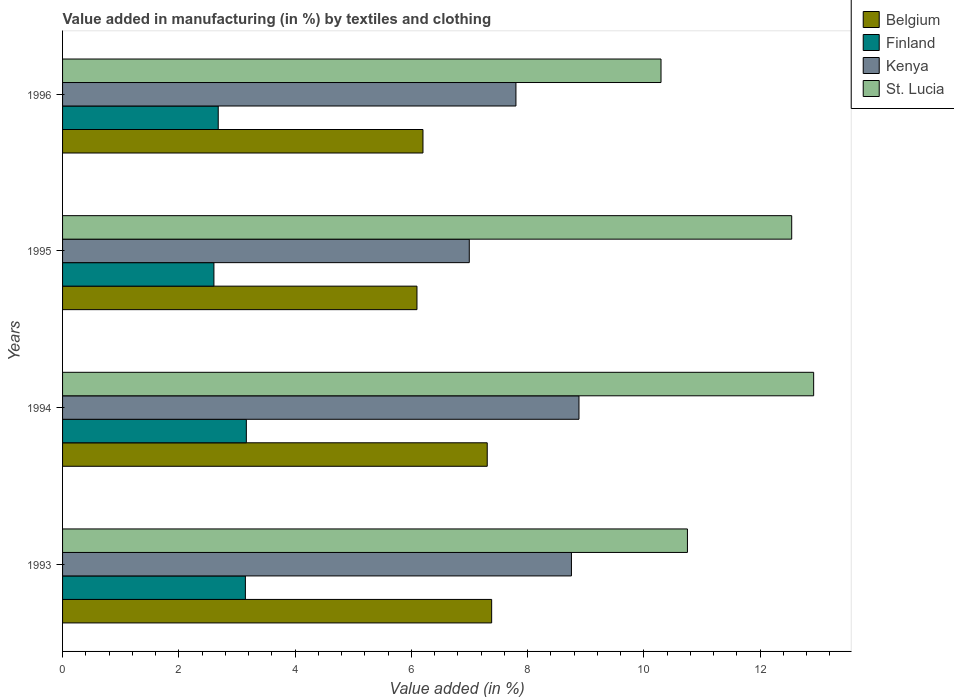Are the number of bars per tick equal to the number of legend labels?
Make the answer very short. Yes. How many bars are there on the 4th tick from the top?
Give a very brief answer. 4. How many bars are there on the 4th tick from the bottom?
Offer a very short reply. 4. What is the label of the 2nd group of bars from the top?
Give a very brief answer. 1995. In how many cases, is the number of bars for a given year not equal to the number of legend labels?
Your response must be concise. 0. What is the percentage of value added in manufacturing by textiles and clothing in St. Lucia in 1993?
Give a very brief answer. 10.75. Across all years, what is the maximum percentage of value added in manufacturing by textiles and clothing in Kenya?
Keep it short and to the point. 8.88. Across all years, what is the minimum percentage of value added in manufacturing by textiles and clothing in St. Lucia?
Provide a succinct answer. 10.29. In which year was the percentage of value added in manufacturing by textiles and clothing in Kenya minimum?
Your response must be concise. 1995. What is the total percentage of value added in manufacturing by textiles and clothing in Finland in the graph?
Keep it short and to the point. 11.59. What is the difference between the percentage of value added in manufacturing by textiles and clothing in Finland in 1994 and that in 1996?
Make the answer very short. 0.48. What is the difference between the percentage of value added in manufacturing by textiles and clothing in Belgium in 1994 and the percentage of value added in manufacturing by textiles and clothing in St. Lucia in 1996?
Make the answer very short. -2.99. What is the average percentage of value added in manufacturing by textiles and clothing in Finland per year?
Provide a succinct answer. 2.9. In the year 1996, what is the difference between the percentage of value added in manufacturing by textiles and clothing in Belgium and percentage of value added in manufacturing by textiles and clothing in Finland?
Keep it short and to the point. 3.52. What is the ratio of the percentage of value added in manufacturing by textiles and clothing in Kenya in 1993 to that in 1995?
Give a very brief answer. 1.25. Is the percentage of value added in manufacturing by textiles and clothing in St. Lucia in 1993 less than that in 1995?
Offer a terse response. Yes. Is the difference between the percentage of value added in manufacturing by textiles and clothing in Belgium in 1994 and 1995 greater than the difference between the percentage of value added in manufacturing by textiles and clothing in Finland in 1994 and 1995?
Offer a very short reply. Yes. What is the difference between the highest and the second highest percentage of value added in manufacturing by textiles and clothing in Kenya?
Offer a terse response. 0.13. What is the difference between the highest and the lowest percentage of value added in manufacturing by textiles and clothing in Belgium?
Offer a very short reply. 1.28. In how many years, is the percentage of value added in manufacturing by textiles and clothing in Finland greater than the average percentage of value added in manufacturing by textiles and clothing in Finland taken over all years?
Give a very brief answer. 2. What does the 4th bar from the bottom in 1995 represents?
Make the answer very short. St. Lucia. How many bars are there?
Provide a succinct answer. 16. What is the difference between two consecutive major ticks on the X-axis?
Keep it short and to the point. 2. Are the values on the major ticks of X-axis written in scientific E-notation?
Make the answer very short. No. Does the graph contain grids?
Your answer should be compact. No. Where does the legend appear in the graph?
Offer a terse response. Top right. How many legend labels are there?
Provide a succinct answer. 4. What is the title of the graph?
Ensure brevity in your answer.  Value added in manufacturing (in %) by textiles and clothing. What is the label or title of the X-axis?
Make the answer very short. Value added (in %). What is the Value added (in %) of Belgium in 1993?
Offer a very short reply. 7.38. What is the Value added (in %) of Finland in 1993?
Your response must be concise. 3.14. What is the Value added (in %) in Kenya in 1993?
Ensure brevity in your answer.  8.75. What is the Value added (in %) in St. Lucia in 1993?
Offer a terse response. 10.75. What is the Value added (in %) in Belgium in 1994?
Your answer should be very brief. 7.3. What is the Value added (in %) of Finland in 1994?
Your response must be concise. 3.16. What is the Value added (in %) in Kenya in 1994?
Your answer should be very brief. 8.88. What is the Value added (in %) in St. Lucia in 1994?
Provide a short and direct response. 12.92. What is the Value added (in %) in Belgium in 1995?
Your answer should be very brief. 6.1. What is the Value added (in %) in Finland in 1995?
Provide a succinct answer. 2.6. What is the Value added (in %) in Kenya in 1995?
Your answer should be compact. 7. What is the Value added (in %) of St. Lucia in 1995?
Your answer should be very brief. 12.54. What is the Value added (in %) of Belgium in 1996?
Your answer should be compact. 6.2. What is the Value added (in %) of Finland in 1996?
Make the answer very short. 2.68. What is the Value added (in %) of Kenya in 1996?
Keep it short and to the point. 7.8. What is the Value added (in %) of St. Lucia in 1996?
Keep it short and to the point. 10.29. Across all years, what is the maximum Value added (in %) in Belgium?
Provide a short and direct response. 7.38. Across all years, what is the maximum Value added (in %) of Finland?
Provide a succinct answer. 3.16. Across all years, what is the maximum Value added (in %) of Kenya?
Your answer should be very brief. 8.88. Across all years, what is the maximum Value added (in %) in St. Lucia?
Provide a succinct answer. 12.92. Across all years, what is the minimum Value added (in %) of Belgium?
Give a very brief answer. 6.1. Across all years, what is the minimum Value added (in %) of Finland?
Provide a succinct answer. 2.6. Across all years, what is the minimum Value added (in %) of Kenya?
Your answer should be very brief. 7. Across all years, what is the minimum Value added (in %) of St. Lucia?
Your answer should be very brief. 10.29. What is the total Value added (in %) in Belgium in the graph?
Give a very brief answer. 26.98. What is the total Value added (in %) in Finland in the graph?
Ensure brevity in your answer.  11.59. What is the total Value added (in %) of Kenya in the graph?
Ensure brevity in your answer.  32.43. What is the total Value added (in %) in St. Lucia in the graph?
Your answer should be compact. 46.51. What is the difference between the Value added (in %) in Belgium in 1993 and that in 1994?
Ensure brevity in your answer.  0.08. What is the difference between the Value added (in %) in Finland in 1993 and that in 1994?
Your response must be concise. -0.02. What is the difference between the Value added (in %) in Kenya in 1993 and that in 1994?
Your response must be concise. -0.13. What is the difference between the Value added (in %) of St. Lucia in 1993 and that in 1994?
Give a very brief answer. -2.17. What is the difference between the Value added (in %) in Belgium in 1993 and that in 1995?
Offer a very short reply. 1.28. What is the difference between the Value added (in %) in Finland in 1993 and that in 1995?
Keep it short and to the point. 0.54. What is the difference between the Value added (in %) in Kenya in 1993 and that in 1995?
Your response must be concise. 1.76. What is the difference between the Value added (in %) of St. Lucia in 1993 and that in 1995?
Make the answer very short. -1.79. What is the difference between the Value added (in %) of Belgium in 1993 and that in 1996?
Keep it short and to the point. 1.18. What is the difference between the Value added (in %) in Finland in 1993 and that in 1996?
Offer a very short reply. 0.47. What is the difference between the Value added (in %) of Kenya in 1993 and that in 1996?
Your answer should be compact. 0.95. What is the difference between the Value added (in %) in St. Lucia in 1993 and that in 1996?
Offer a very short reply. 0.45. What is the difference between the Value added (in %) of Belgium in 1994 and that in 1995?
Ensure brevity in your answer.  1.21. What is the difference between the Value added (in %) in Finland in 1994 and that in 1995?
Provide a short and direct response. 0.56. What is the difference between the Value added (in %) in Kenya in 1994 and that in 1995?
Offer a very short reply. 1.89. What is the difference between the Value added (in %) in St. Lucia in 1994 and that in 1995?
Make the answer very short. 0.38. What is the difference between the Value added (in %) of Belgium in 1994 and that in 1996?
Keep it short and to the point. 1.11. What is the difference between the Value added (in %) of Finland in 1994 and that in 1996?
Offer a very short reply. 0.48. What is the difference between the Value added (in %) of Kenya in 1994 and that in 1996?
Offer a very short reply. 1.08. What is the difference between the Value added (in %) in St. Lucia in 1994 and that in 1996?
Your answer should be very brief. 2.63. What is the difference between the Value added (in %) of Belgium in 1995 and that in 1996?
Ensure brevity in your answer.  -0.1. What is the difference between the Value added (in %) in Finland in 1995 and that in 1996?
Give a very brief answer. -0.07. What is the difference between the Value added (in %) of Kenya in 1995 and that in 1996?
Your answer should be compact. -0.8. What is the difference between the Value added (in %) of St. Lucia in 1995 and that in 1996?
Ensure brevity in your answer.  2.25. What is the difference between the Value added (in %) in Belgium in 1993 and the Value added (in %) in Finland in 1994?
Offer a very short reply. 4.22. What is the difference between the Value added (in %) in Belgium in 1993 and the Value added (in %) in Kenya in 1994?
Keep it short and to the point. -1.5. What is the difference between the Value added (in %) of Belgium in 1993 and the Value added (in %) of St. Lucia in 1994?
Provide a short and direct response. -5.54. What is the difference between the Value added (in %) in Finland in 1993 and the Value added (in %) in Kenya in 1994?
Your answer should be compact. -5.74. What is the difference between the Value added (in %) in Finland in 1993 and the Value added (in %) in St. Lucia in 1994?
Ensure brevity in your answer.  -9.78. What is the difference between the Value added (in %) of Kenya in 1993 and the Value added (in %) of St. Lucia in 1994?
Your answer should be very brief. -4.17. What is the difference between the Value added (in %) in Belgium in 1993 and the Value added (in %) in Finland in 1995?
Offer a very short reply. 4.78. What is the difference between the Value added (in %) in Belgium in 1993 and the Value added (in %) in Kenya in 1995?
Your response must be concise. 0.38. What is the difference between the Value added (in %) of Belgium in 1993 and the Value added (in %) of St. Lucia in 1995?
Offer a very short reply. -5.16. What is the difference between the Value added (in %) of Finland in 1993 and the Value added (in %) of Kenya in 1995?
Give a very brief answer. -3.85. What is the difference between the Value added (in %) in Finland in 1993 and the Value added (in %) in St. Lucia in 1995?
Provide a succinct answer. -9.4. What is the difference between the Value added (in %) of Kenya in 1993 and the Value added (in %) of St. Lucia in 1995?
Provide a short and direct response. -3.79. What is the difference between the Value added (in %) in Belgium in 1993 and the Value added (in %) in Finland in 1996?
Your answer should be very brief. 4.7. What is the difference between the Value added (in %) of Belgium in 1993 and the Value added (in %) of Kenya in 1996?
Your answer should be very brief. -0.42. What is the difference between the Value added (in %) in Belgium in 1993 and the Value added (in %) in St. Lucia in 1996?
Your answer should be very brief. -2.91. What is the difference between the Value added (in %) of Finland in 1993 and the Value added (in %) of Kenya in 1996?
Make the answer very short. -4.65. What is the difference between the Value added (in %) in Finland in 1993 and the Value added (in %) in St. Lucia in 1996?
Your answer should be very brief. -7.15. What is the difference between the Value added (in %) of Kenya in 1993 and the Value added (in %) of St. Lucia in 1996?
Ensure brevity in your answer.  -1.54. What is the difference between the Value added (in %) in Belgium in 1994 and the Value added (in %) in Finland in 1995?
Your answer should be compact. 4.7. What is the difference between the Value added (in %) in Belgium in 1994 and the Value added (in %) in Kenya in 1995?
Your response must be concise. 0.31. What is the difference between the Value added (in %) in Belgium in 1994 and the Value added (in %) in St. Lucia in 1995?
Provide a short and direct response. -5.24. What is the difference between the Value added (in %) in Finland in 1994 and the Value added (in %) in Kenya in 1995?
Keep it short and to the point. -3.83. What is the difference between the Value added (in %) in Finland in 1994 and the Value added (in %) in St. Lucia in 1995?
Provide a short and direct response. -9.38. What is the difference between the Value added (in %) in Kenya in 1994 and the Value added (in %) in St. Lucia in 1995?
Your answer should be very brief. -3.66. What is the difference between the Value added (in %) of Belgium in 1994 and the Value added (in %) of Finland in 1996?
Provide a succinct answer. 4.63. What is the difference between the Value added (in %) in Belgium in 1994 and the Value added (in %) in Kenya in 1996?
Provide a succinct answer. -0.49. What is the difference between the Value added (in %) in Belgium in 1994 and the Value added (in %) in St. Lucia in 1996?
Your response must be concise. -2.99. What is the difference between the Value added (in %) in Finland in 1994 and the Value added (in %) in Kenya in 1996?
Provide a short and direct response. -4.64. What is the difference between the Value added (in %) in Finland in 1994 and the Value added (in %) in St. Lucia in 1996?
Offer a terse response. -7.13. What is the difference between the Value added (in %) in Kenya in 1994 and the Value added (in %) in St. Lucia in 1996?
Offer a terse response. -1.41. What is the difference between the Value added (in %) in Belgium in 1995 and the Value added (in %) in Finland in 1996?
Your response must be concise. 3.42. What is the difference between the Value added (in %) of Belgium in 1995 and the Value added (in %) of Kenya in 1996?
Provide a short and direct response. -1.7. What is the difference between the Value added (in %) in Belgium in 1995 and the Value added (in %) in St. Lucia in 1996?
Your answer should be very brief. -4.2. What is the difference between the Value added (in %) in Finland in 1995 and the Value added (in %) in Kenya in 1996?
Your response must be concise. -5.2. What is the difference between the Value added (in %) of Finland in 1995 and the Value added (in %) of St. Lucia in 1996?
Your answer should be compact. -7.69. What is the difference between the Value added (in %) of Kenya in 1995 and the Value added (in %) of St. Lucia in 1996?
Ensure brevity in your answer.  -3.3. What is the average Value added (in %) in Belgium per year?
Your response must be concise. 6.75. What is the average Value added (in %) of Finland per year?
Offer a very short reply. 2.9. What is the average Value added (in %) in Kenya per year?
Ensure brevity in your answer.  8.11. What is the average Value added (in %) in St. Lucia per year?
Provide a succinct answer. 11.63. In the year 1993, what is the difference between the Value added (in %) in Belgium and Value added (in %) in Finland?
Your answer should be very brief. 4.24. In the year 1993, what is the difference between the Value added (in %) of Belgium and Value added (in %) of Kenya?
Your answer should be compact. -1.37. In the year 1993, what is the difference between the Value added (in %) in Belgium and Value added (in %) in St. Lucia?
Give a very brief answer. -3.37. In the year 1993, what is the difference between the Value added (in %) of Finland and Value added (in %) of Kenya?
Your response must be concise. -5.61. In the year 1993, what is the difference between the Value added (in %) in Finland and Value added (in %) in St. Lucia?
Ensure brevity in your answer.  -7.6. In the year 1993, what is the difference between the Value added (in %) of Kenya and Value added (in %) of St. Lucia?
Your response must be concise. -2. In the year 1994, what is the difference between the Value added (in %) in Belgium and Value added (in %) in Finland?
Keep it short and to the point. 4.14. In the year 1994, what is the difference between the Value added (in %) of Belgium and Value added (in %) of Kenya?
Offer a very short reply. -1.58. In the year 1994, what is the difference between the Value added (in %) of Belgium and Value added (in %) of St. Lucia?
Your response must be concise. -5.62. In the year 1994, what is the difference between the Value added (in %) of Finland and Value added (in %) of Kenya?
Make the answer very short. -5.72. In the year 1994, what is the difference between the Value added (in %) in Finland and Value added (in %) in St. Lucia?
Offer a terse response. -9.76. In the year 1994, what is the difference between the Value added (in %) of Kenya and Value added (in %) of St. Lucia?
Provide a short and direct response. -4.04. In the year 1995, what is the difference between the Value added (in %) of Belgium and Value added (in %) of Finland?
Offer a terse response. 3.49. In the year 1995, what is the difference between the Value added (in %) in Belgium and Value added (in %) in Kenya?
Ensure brevity in your answer.  -0.9. In the year 1995, what is the difference between the Value added (in %) of Belgium and Value added (in %) of St. Lucia?
Offer a very short reply. -6.45. In the year 1995, what is the difference between the Value added (in %) of Finland and Value added (in %) of Kenya?
Ensure brevity in your answer.  -4.39. In the year 1995, what is the difference between the Value added (in %) of Finland and Value added (in %) of St. Lucia?
Offer a terse response. -9.94. In the year 1995, what is the difference between the Value added (in %) in Kenya and Value added (in %) in St. Lucia?
Your response must be concise. -5.55. In the year 1996, what is the difference between the Value added (in %) in Belgium and Value added (in %) in Finland?
Make the answer very short. 3.52. In the year 1996, what is the difference between the Value added (in %) in Belgium and Value added (in %) in Kenya?
Your answer should be very brief. -1.6. In the year 1996, what is the difference between the Value added (in %) of Belgium and Value added (in %) of St. Lucia?
Provide a short and direct response. -4.09. In the year 1996, what is the difference between the Value added (in %) of Finland and Value added (in %) of Kenya?
Give a very brief answer. -5.12. In the year 1996, what is the difference between the Value added (in %) in Finland and Value added (in %) in St. Lucia?
Your answer should be very brief. -7.62. In the year 1996, what is the difference between the Value added (in %) of Kenya and Value added (in %) of St. Lucia?
Offer a very short reply. -2.5. What is the ratio of the Value added (in %) of Belgium in 1993 to that in 1994?
Make the answer very short. 1.01. What is the ratio of the Value added (in %) in Kenya in 1993 to that in 1994?
Ensure brevity in your answer.  0.99. What is the ratio of the Value added (in %) of St. Lucia in 1993 to that in 1994?
Your answer should be compact. 0.83. What is the ratio of the Value added (in %) in Belgium in 1993 to that in 1995?
Offer a very short reply. 1.21. What is the ratio of the Value added (in %) in Finland in 1993 to that in 1995?
Give a very brief answer. 1.21. What is the ratio of the Value added (in %) of Kenya in 1993 to that in 1995?
Offer a very short reply. 1.25. What is the ratio of the Value added (in %) in St. Lucia in 1993 to that in 1995?
Your response must be concise. 0.86. What is the ratio of the Value added (in %) of Belgium in 1993 to that in 1996?
Your answer should be compact. 1.19. What is the ratio of the Value added (in %) in Finland in 1993 to that in 1996?
Give a very brief answer. 1.17. What is the ratio of the Value added (in %) in Kenya in 1993 to that in 1996?
Offer a very short reply. 1.12. What is the ratio of the Value added (in %) of St. Lucia in 1993 to that in 1996?
Your response must be concise. 1.04. What is the ratio of the Value added (in %) in Belgium in 1994 to that in 1995?
Your answer should be compact. 1.2. What is the ratio of the Value added (in %) of Finland in 1994 to that in 1995?
Provide a short and direct response. 1.21. What is the ratio of the Value added (in %) in Kenya in 1994 to that in 1995?
Provide a succinct answer. 1.27. What is the ratio of the Value added (in %) in St. Lucia in 1994 to that in 1995?
Your response must be concise. 1.03. What is the ratio of the Value added (in %) of Belgium in 1994 to that in 1996?
Your answer should be very brief. 1.18. What is the ratio of the Value added (in %) in Finland in 1994 to that in 1996?
Your response must be concise. 1.18. What is the ratio of the Value added (in %) in Kenya in 1994 to that in 1996?
Ensure brevity in your answer.  1.14. What is the ratio of the Value added (in %) in St. Lucia in 1994 to that in 1996?
Your answer should be very brief. 1.26. What is the ratio of the Value added (in %) in Belgium in 1995 to that in 1996?
Your answer should be compact. 0.98. What is the ratio of the Value added (in %) in Finland in 1995 to that in 1996?
Make the answer very short. 0.97. What is the ratio of the Value added (in %) in Kenya in 1995 to that in 1996?
Your response must be concise. 0.9. What is the ratio of the Value added (in %) in St. Lucia in 1995 to that in 1996?
Ensure brevity in your answer.  1.22. What is the difference between the highest and the second highest Value added (in %) in Belgium?
Your answer should be compact. 0.08. What is the difference between the highest and the second highest Value added (in %) of Finland?
Make the answer very short. 0.02. What is the difference between the highest and the second highest Value added (in %) in Kenya?
Your answer should be compact. 0.13. What is the difference between the highest and the second highest Value added (in %) in St. Lucia?
Keep it short and to the point. 0.38. What is the difference between the highest and the lowest Value added (in %) of Belgium?
Provide a short and direct response. 1.28. What is the difference between the highest and the lowest Value added (in %) in Finland?
Make the answer very short. 0.56. What is the difference between the highest and the lowest Value added (in %) in Kenya?
Your response must be concise. 1.89. What is the difference between the highest and the lowest Value added (in %) of St. Lucia?
Provide a succinct answer. 2.63. 